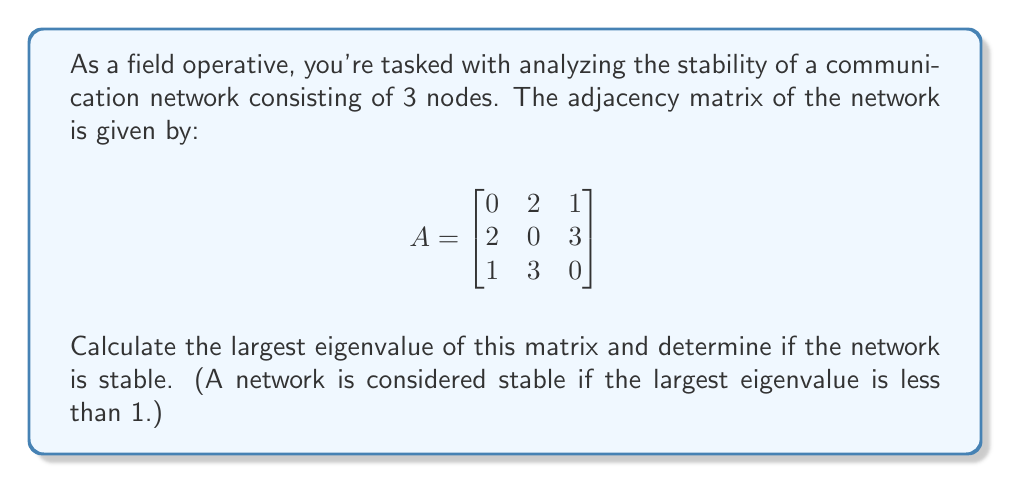Can you solve this math problem? 1) To find the eigenvalues, we need to solve the characteristic equation:
   $$det(A - \lambda I) = 0$$

2) Expanding this determinant:
   $$\begin{vmatrix}
   -\lambda & 2 & 1 \\
   2 & -\lambda & 3 \\
   1 & 3 & -\lambda
   \end{vmatrix} = 0$$

3) This gives us the characteristic polynomial:
   $$-\lambda^3 + 14\lambda + 12 = 0$$

4) Using the cubic formula or numerical methods, we can find the roots of this polynomial. The eigenvalues are approximately:
   $$\lambda_1 \approx 4.30$$
   $$\lambda_2 \approx -2.30$$
   $$\lambda_3 \approx -2.00$$

5) The largest eigenvalue is $\lambda_1 \approx 4.30$.

6) Since 4.30 > 1, the network is not stable according to the given criterion.
Answer: Unstable; largest eigenvalue ≈ 4.30 > 1 